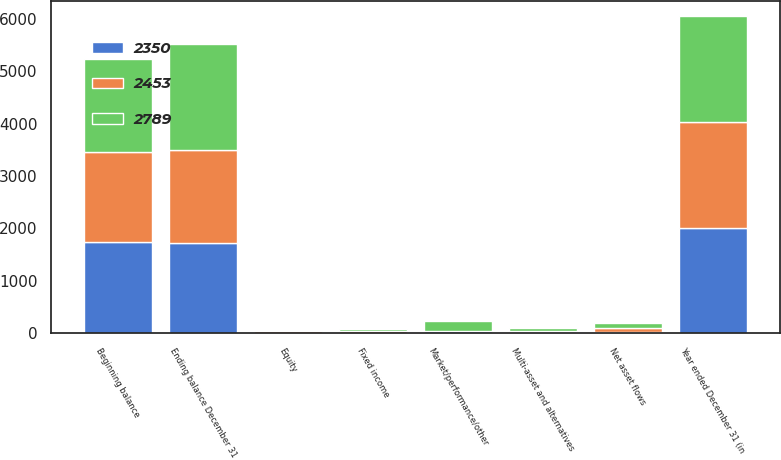Convert chart to OTSL. <chart><loc_0><loc_0><loc_500><loc_500><stacked_bar_chart><ecel><fcel>Year ended December 31 (in<fcel>Beginning balance<fcel>Fixed income<fcel>Equity<fcel>Multi-asset and alternatives<fcel>Market/performance/other<fcel>Ending balance December 31<fcel>Net asset flows<nl><fcel>2789<fcel>2017<fcel>1771<fcel>36<fcel>11<fcel>43<fcel>186<fcel>2034<fcel>93<nl><fcel>2453<fcel>2016<fcel>1723<fcel>30<fcel>29<fcel>22<fcel>1<fcel>1771<fcel>63<nl><fcel>2350<fcel>2015<fcel>1744<fcel>8<fcel>1<fcel>22<fcel>36<fcel>1723<fcel>27<nl></chart> 